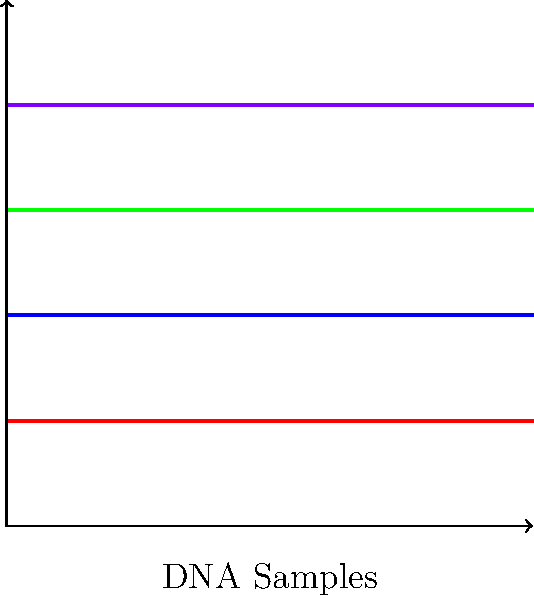In a DNA analysis for a post-conviction case, you receive the results of gel electrophoresis as shown in the image. Sample 1 (S1) belongs to the convicted individual, while Samples 2-4 (S2-S4) are from different pieces of evidence. Which sample(s) potentially match the convicted individual's DNA profile, and how might this impact your appeal strategy? To answer this question, we need to analyze the gel electrophoresis results step-by-step:

1. Understanding gel electrophoresis: DNA fragments migrate through the gel based on size, with smaller fragments moving faster (further down the gel).

2. Interpreting the results:
   - S1 (red) represents the convicted individual's DNA profile.
   - S2 (blue), S3 (green), and S4 (purple) are from different pieces of evidence.

3. Comparing the samples:
   - S1 and S3 show identical band patterns, indicating a potential match.
   - S2 and S4 have different band patterns from S1, suggesting they don't match the convicted individual's DNA.

4. Legal implications:
   - The match between S1 and S3 could either support or challenge the conviction, depending on the context of the evidence.
   - The non-matching samples (S2 and S4) might introduce reasonable doubt or point to alternative suspects.

5. Appeal strategy:
   - If S3 is from a key piece of evidence that ties the convicted individual to the crime scene, it may strengthen the prosecution's case.
   - However, if S3 is from evidence that shouldn't match the convicted individual based on the prosecution's theory, it could be grounds for appeal.
   - The non-matching samples (S2 and S4) could be used to argue for the presence of other individuals at the crime scene or alternative explanations for the evidence.

6. Next steps:
   - Investigate the sources of S2, S3, and S4 in detail.
   - Consider requesting additional DNA testing or analysis if beneficial to the case.
   - Evaluate how this new DNA evidence fits with other aspects of the case and the original trial proceedings.
Answer: S3 potentially matches; reevaluate case based on S3's source and inconsistency with S2 and S4. 